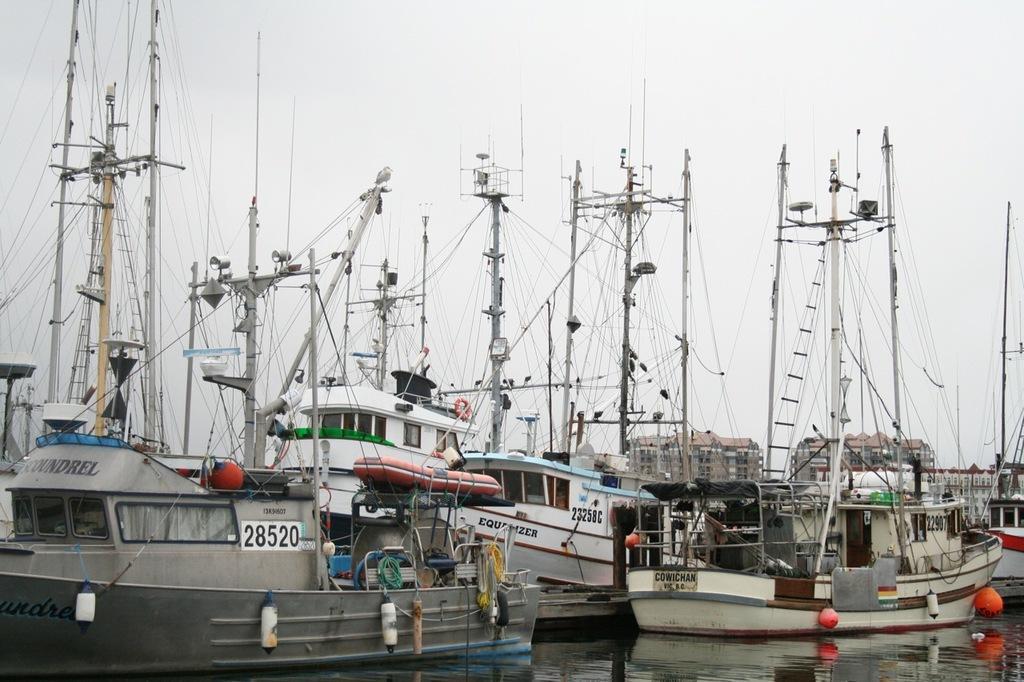Could you give a brief overview of what you see in this image? At the center of the image there are many boats are on the water. In the background there is a sky. 